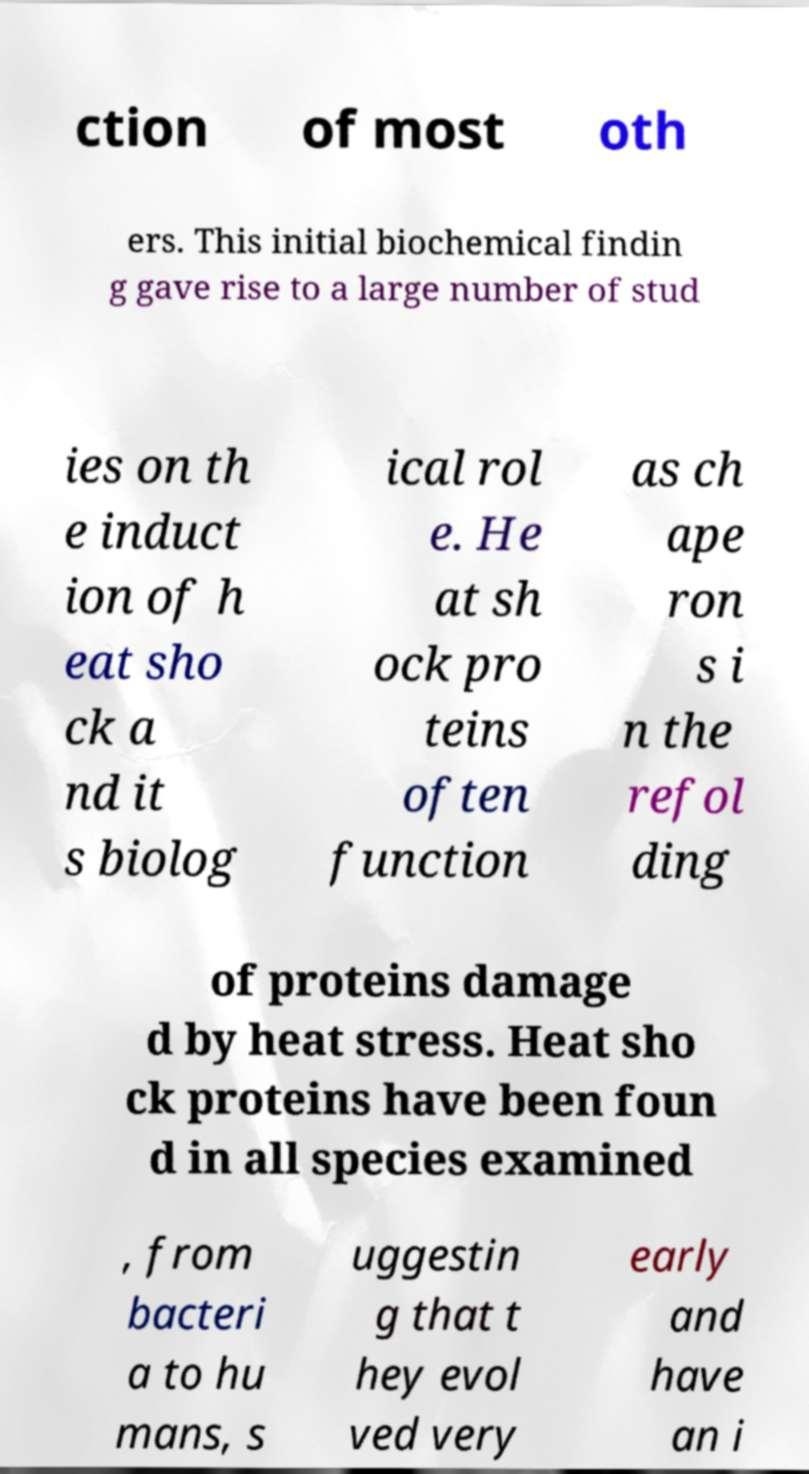Can you accurately transcribe the text from the provided image for me? ction of most oth ers. This initial biochemical findin g gave rise to a large number of stud ies on th e induct ion of h eat sho ck a nd it s biolog ical rol e. He at sh ock pro teins often function as ch ape ron s i n the refol ding of proteins damage d by heat stress. Heat sho ck proteins have been foun d in all species examined , from bacteri a to hu mans, s uggestin g that t hey evol ved very early and have an i 